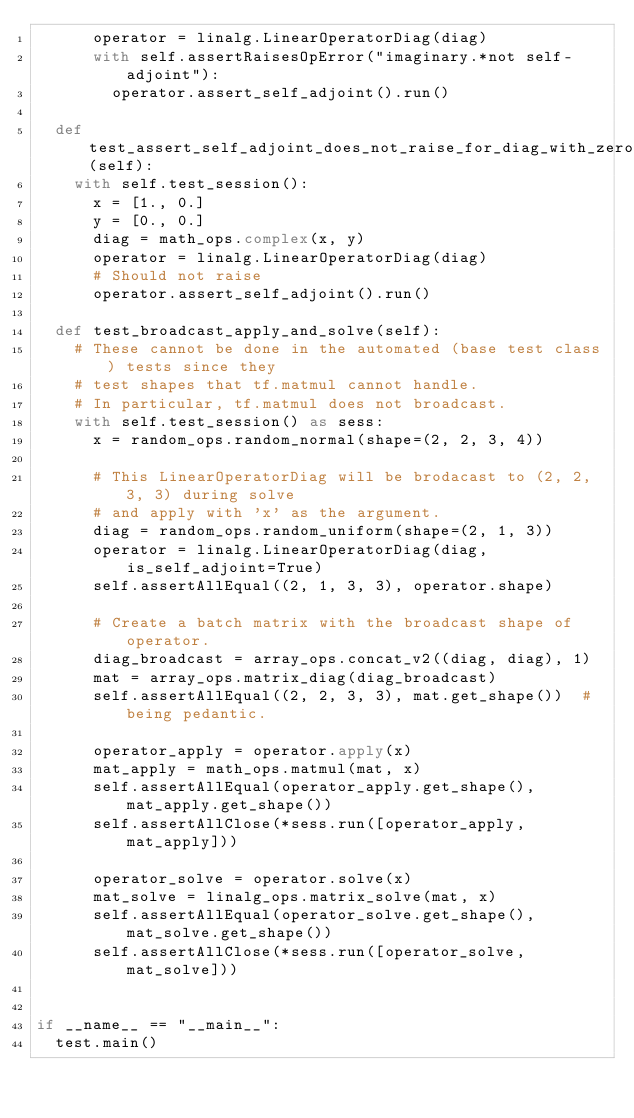Convert code to text. <code><loc_0><loc_0><loc_500><loc_500><_Python_>      operator = linalg.LinearOperatorDiag(diag)
      with self.assertRaisesOpError("imaginary.*not self-adjoint"):
        operator.assert_self_adjoint().run()

  def test_assert_self_adjoint_does_not_raise_for_diag_with_zero_imag(self):
    with self.test_session():
      x = [1., 0.]
      y = [0., 0.]
      diag = math_ops.complex(x, y)
      operator = linalg.LinearOperatorDiag(diag)
      # Should not raise
      operator.assert_self_adjoint().run()

  def test_broadcast_apply_and_solve(self):
    # These cannot be done in the automated (base test class) tests since they
    # test shapes that tf.matmul cannot handle.
    # In particular, tf.matmul does not broadcast.
    with self.test_session() as sess:
      x = random_ops.random_normal(shape=(2, 2, 3, 4))

      # This LinearOperatorDiag will be brodacast to (2, 2, 3, 3) during solve
      # and apply with 'x' as the argument.
      diag = random_ops.random_uniform(shape=(2, 1, 3))
      operator = linalg.LinearOperatorDiag(diag, is_self_adjoint=True)
      self.assertAllEqual((2, 1, 3, 3), operator.shape)

      # Create a batch matrix with the broadcast shape of operator.
      diag_broadcast = array_ops.concat_v2((diag, diag), 1)
      mat = array_ops.matrix_diag(diag_broadcast)
      self.assertAllEqual((2, 2, 3, 3), mat.get_shape())  # being pedantic.

      operator_apply = operator.apply(x)
      mat_apply = math_ops.matmul(mat, x)
      self.assertAllEqual(operator_apply.get_shape(), mat_apply.get_shape())
      self.assertAllClose(*sess.run([operator_apply, mat_apply]))

      operator_solve = operator.solve(x)
      mat_solve = linalg_ops.matrix_solve(mat, x)
      self.assertAllEqual(operator_solve.get_shape(), mat_solve.get_shape())
      self.assertAllClose(*sess.run([operator_solve, mat_solve]))


if __name__ == "__main__":
  test.main()
</code> 